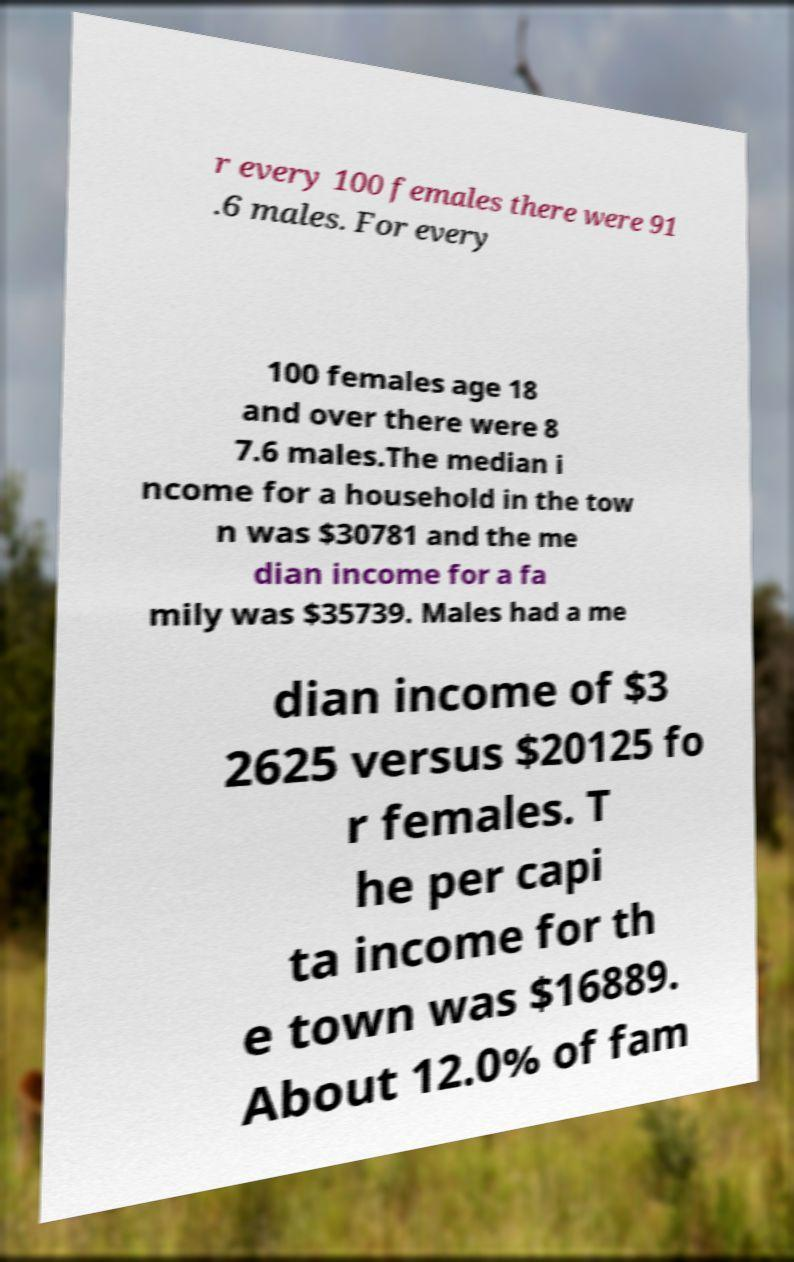There's text embedded in this image that I need extracted. Can you transcribe it verbatim? r every 100 females there were 91 .6 males. For every 100 females age 18 and over there were 8 7.6 males.The median i ncome for a household in the tow n was $30781 and the me dian income for a fa mily was $35739. Males had a me dian income of $3 2625 versus $20125 fo r females. T he per capi ta income for th e town was $16889. About 12.0% of fam 